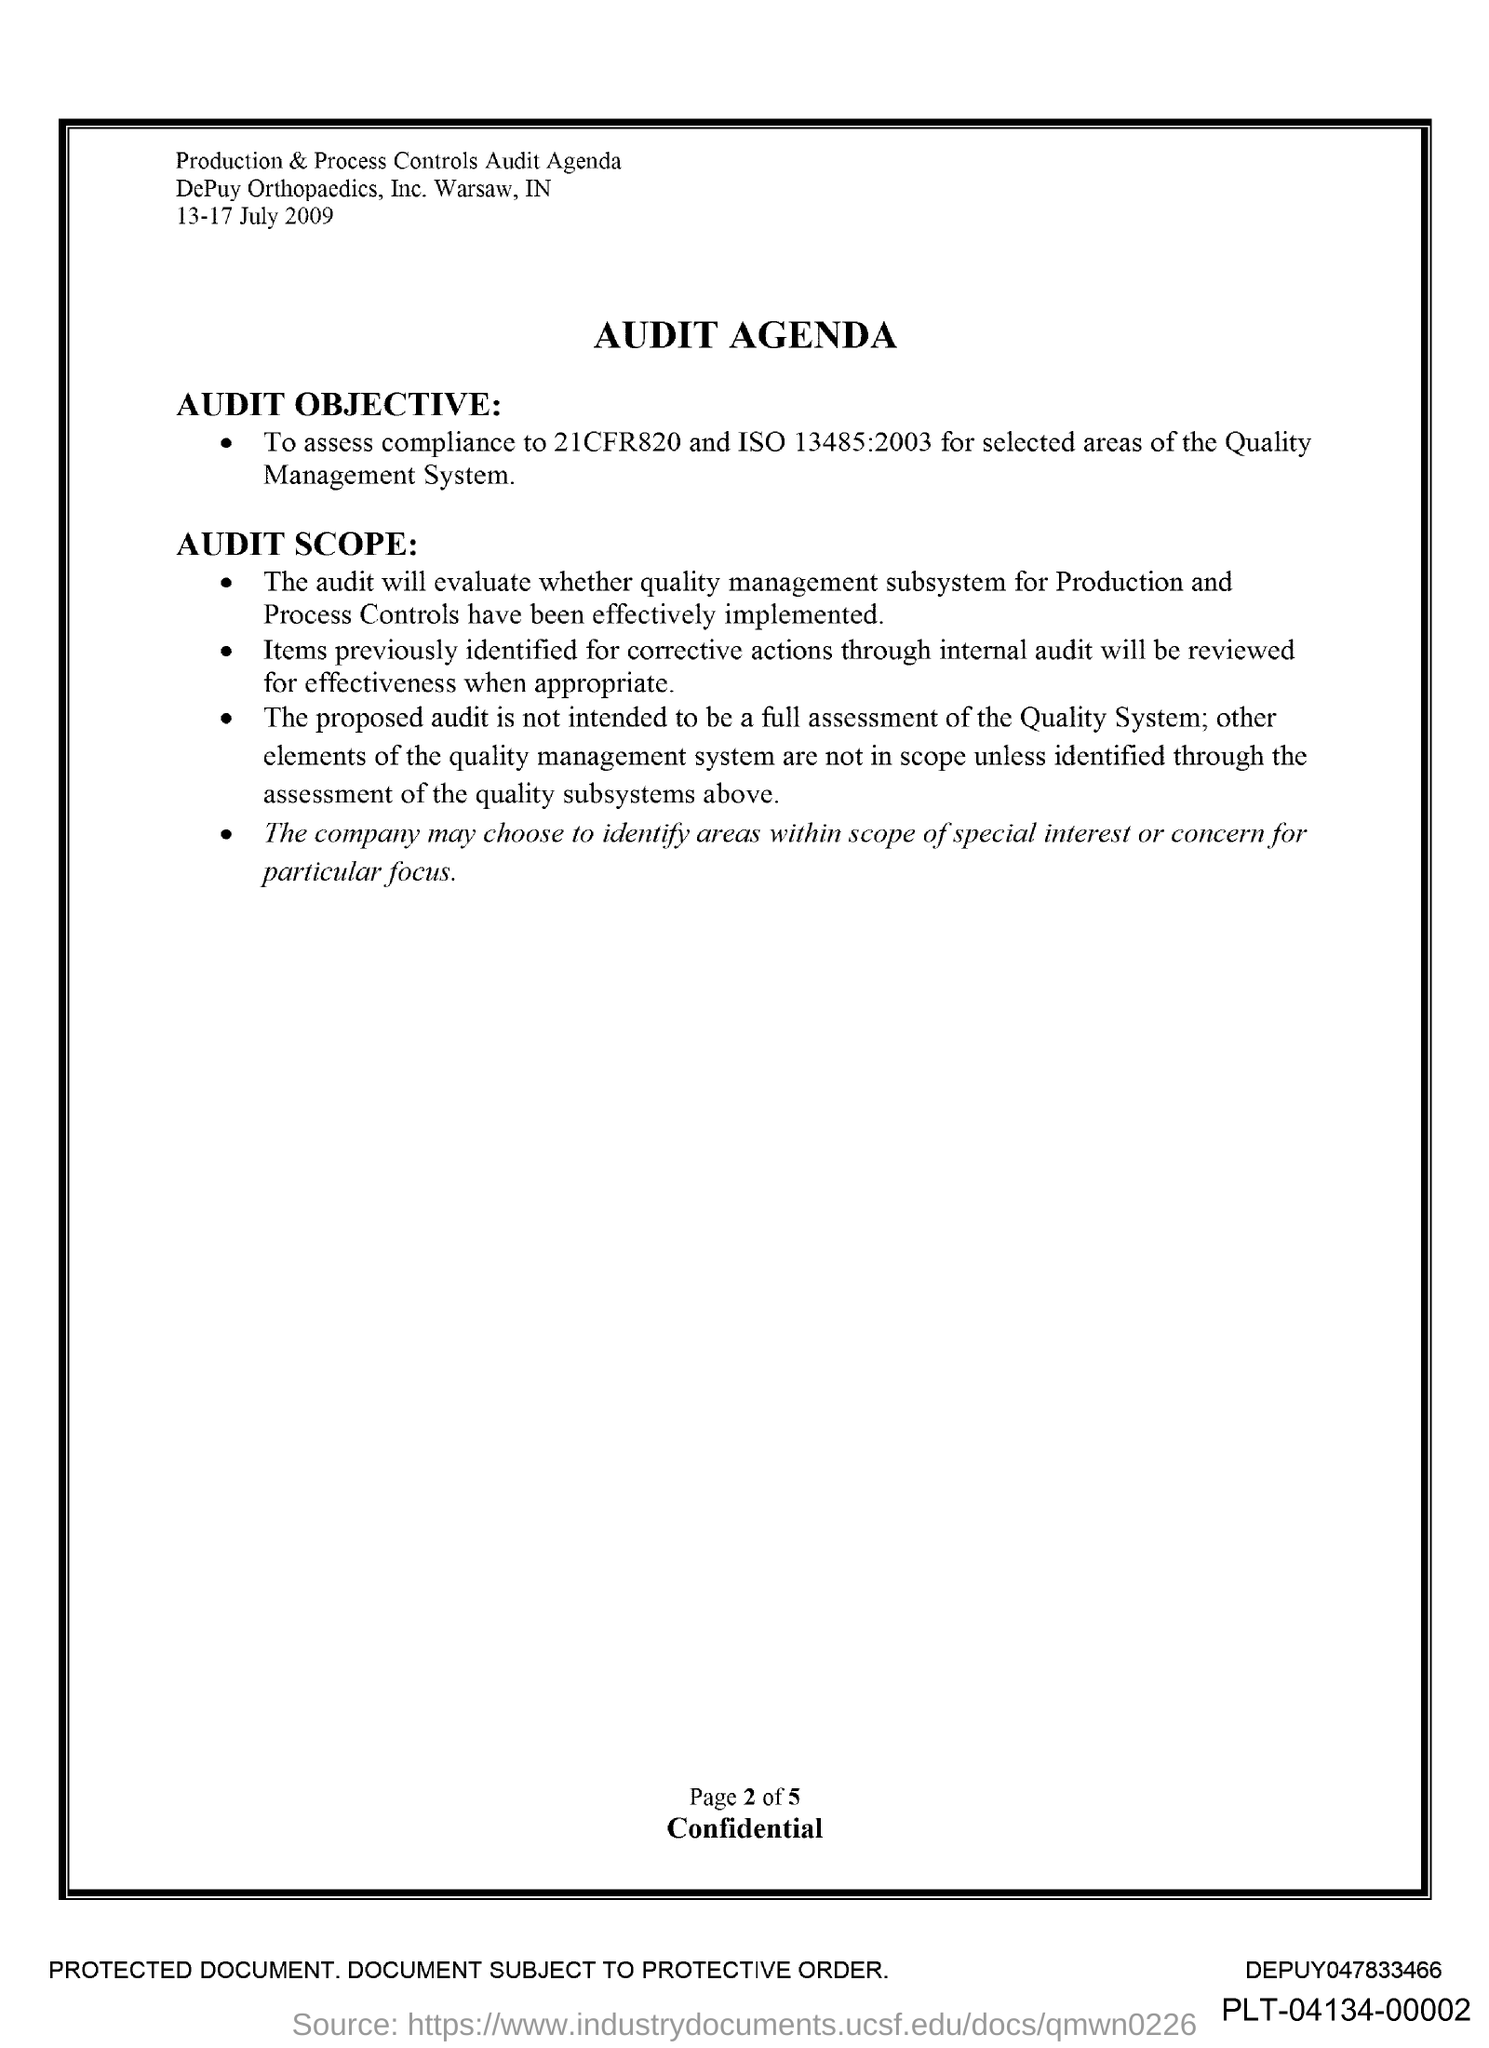What is the document about?
Keep it short and to the point. AUDIT AGENDA. What is the date given?
Give a very brief answer. 13-17 July 2009. Which page is this?
Ensure brevity in your answer.  Page 2 of 5. 